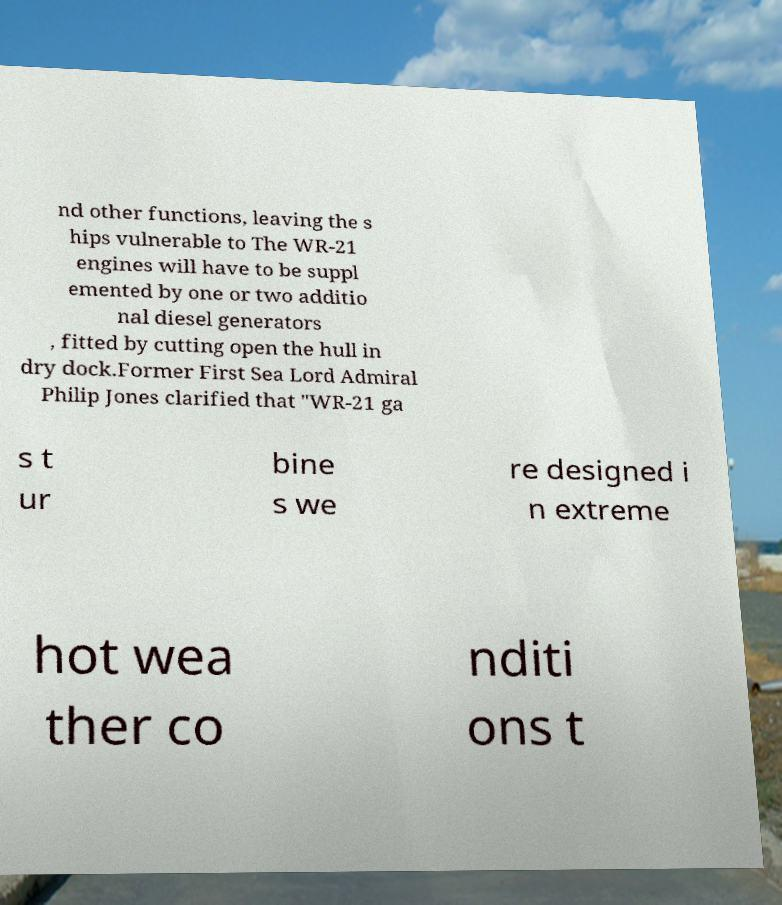There's text embedded in this image that I need extracted. Can you transcribe it verbatim? nd other functions, leaving the s hips vulnerable to The WR-21 engines will have to be suppl emented by one or two additio nal diesel generators , fitted by cutting open the hull in dry dock.Former First Sea Lord Admiral Philip Jones clarified that "WR-21 ga s t ur bine s we re designed i n extreme hot wea ther co nditi ons t 